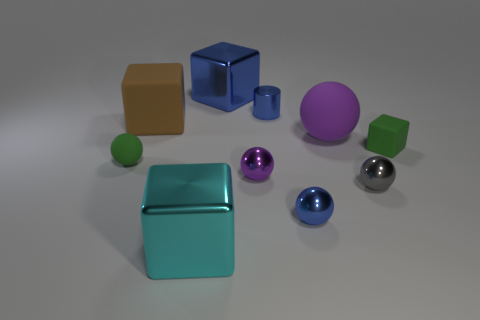Subtract all purple balls. How many were subtracted if there are1purple balls left? 1 Subtract all large balls. How many balls are left? 4 Subtract all yellow balls. Subtract all yellow blocks. How many balls are left? 5 Subtract all cylinders. How many objects are left? 9 Subtract all big spheres. Subtract all small cyan metallic cubes. How many objects are left? 9 Add 6 tiny purple things. How many tiny purple things are left? 7 Add 8 small red metal cubes. How many small red metal cubes exist? 8 Subtract 0 cyan spheres. How many objects are left? 10 